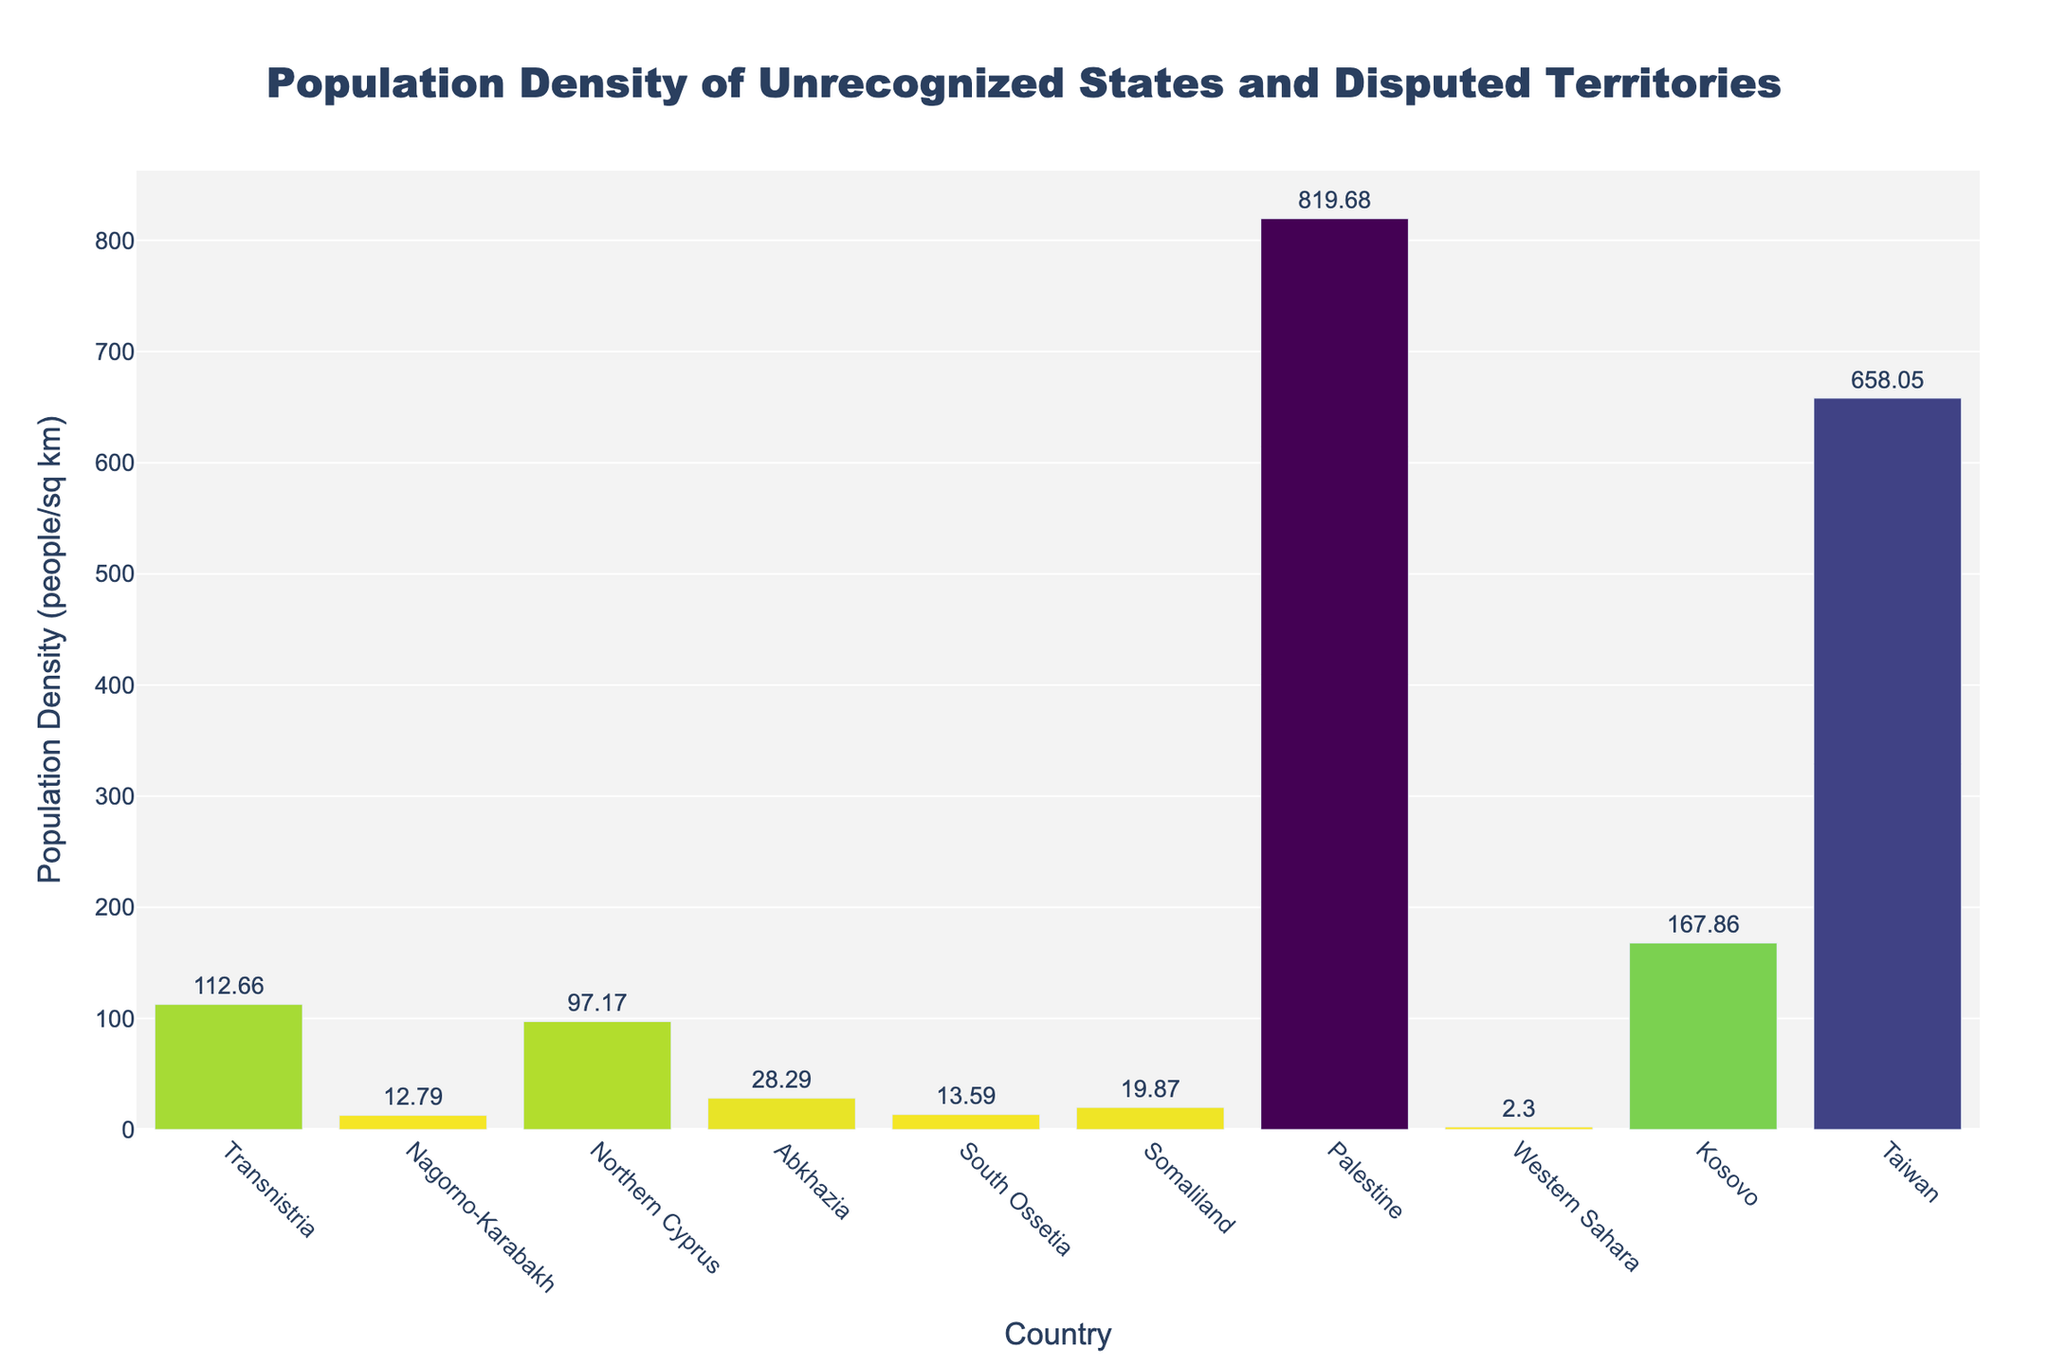How many countries are shown in the figure? Count the number of bars present in the figure.
Answer: 10 Which country has the highest population density? Identify the tallest bar in the figure, which represents the highest population density.
Answer: Palestine Which country has the lowest population density? Identify the shortest bar in the figure, which represents the lowest population density.
Answer: Western Sahara What is the population density of Transnistria? Look at the label outside the bar for Transnistria, which shows the population density.
Answer: 112.68 people/sq km What is the range of population densities among the countries? Find the difference between the highest and lowest population densities shown in the bars. The highest is Palestine, and the lowest is Western Sahara.
Answer: 819.71 people/sq km How does the population density of Taiwan compare to that of Somaliland? Compare the heights of the bars for Taiwan and Somaliland. Taiwan has a higher bar, indicating greater population density.
Answer: Taiwan is higher What is the average population density of all the countries? Sum the population densities from each bar and divide by the number of countries (10). Population densities: 112.68, 12.8, 97.14, 28.29, 13.59, 19.87, 819.71, 2.3, 167.88, 658.21. Average = (112.68 + 12.8 + 97.14 + 28.29 + 13.59 + 19.87 + 819.71 + 2.3 + 167.88 + 658.21) / 10 = 193.65 people/sq km
Answer: 193.65 people/sq km Which territory has a population density closest to 100 people/sq km? Identify the bar whose density label is closest to 100. Transnistria has the closest density with 112.68 people/sq km.
Answer: Transnistria How many countries have a population density above 100 people/sq km? Count the number of bars where the population density label is greater than 100.
Answer: 4 Which country has a population density that is roughly half of Taiwan's? Find Taiwan's population density and then find the bar with a density closest to half of that value (329.1 people/sq km). Transnistria's density is closest.
Answer: Transnistria 